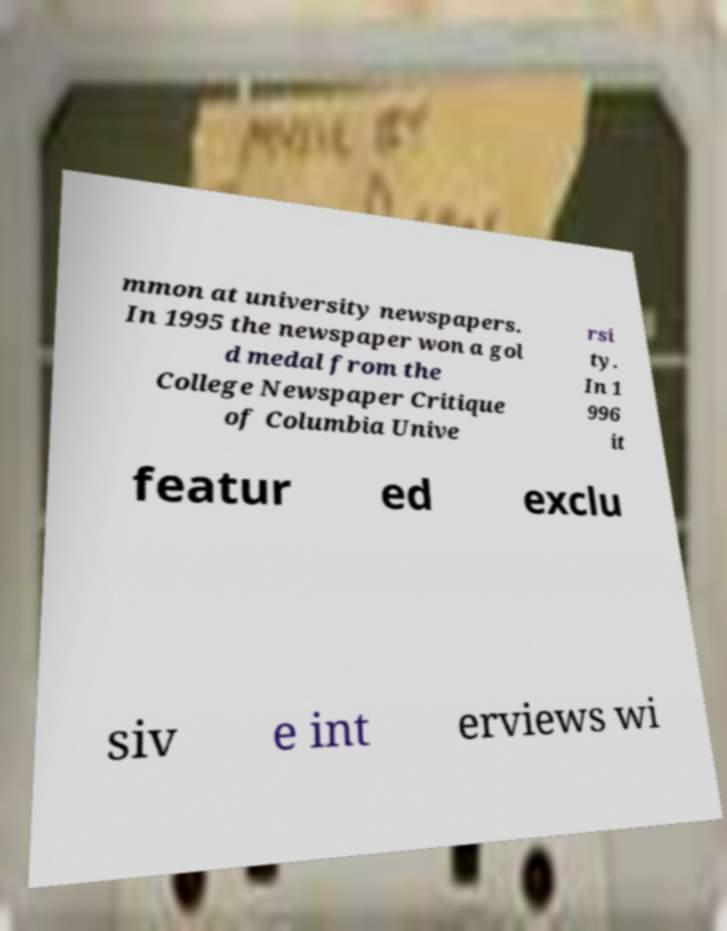There's text embedded in this image that I need extracted. Can you transcribe it verbatim? mmon at university newspapers. In 1995 the newspaper won a gol d medal from the College Newspaper Critique of Columbia Unive rsi ty. In 1 996 it featur ed exclu siv e int erviews wi 